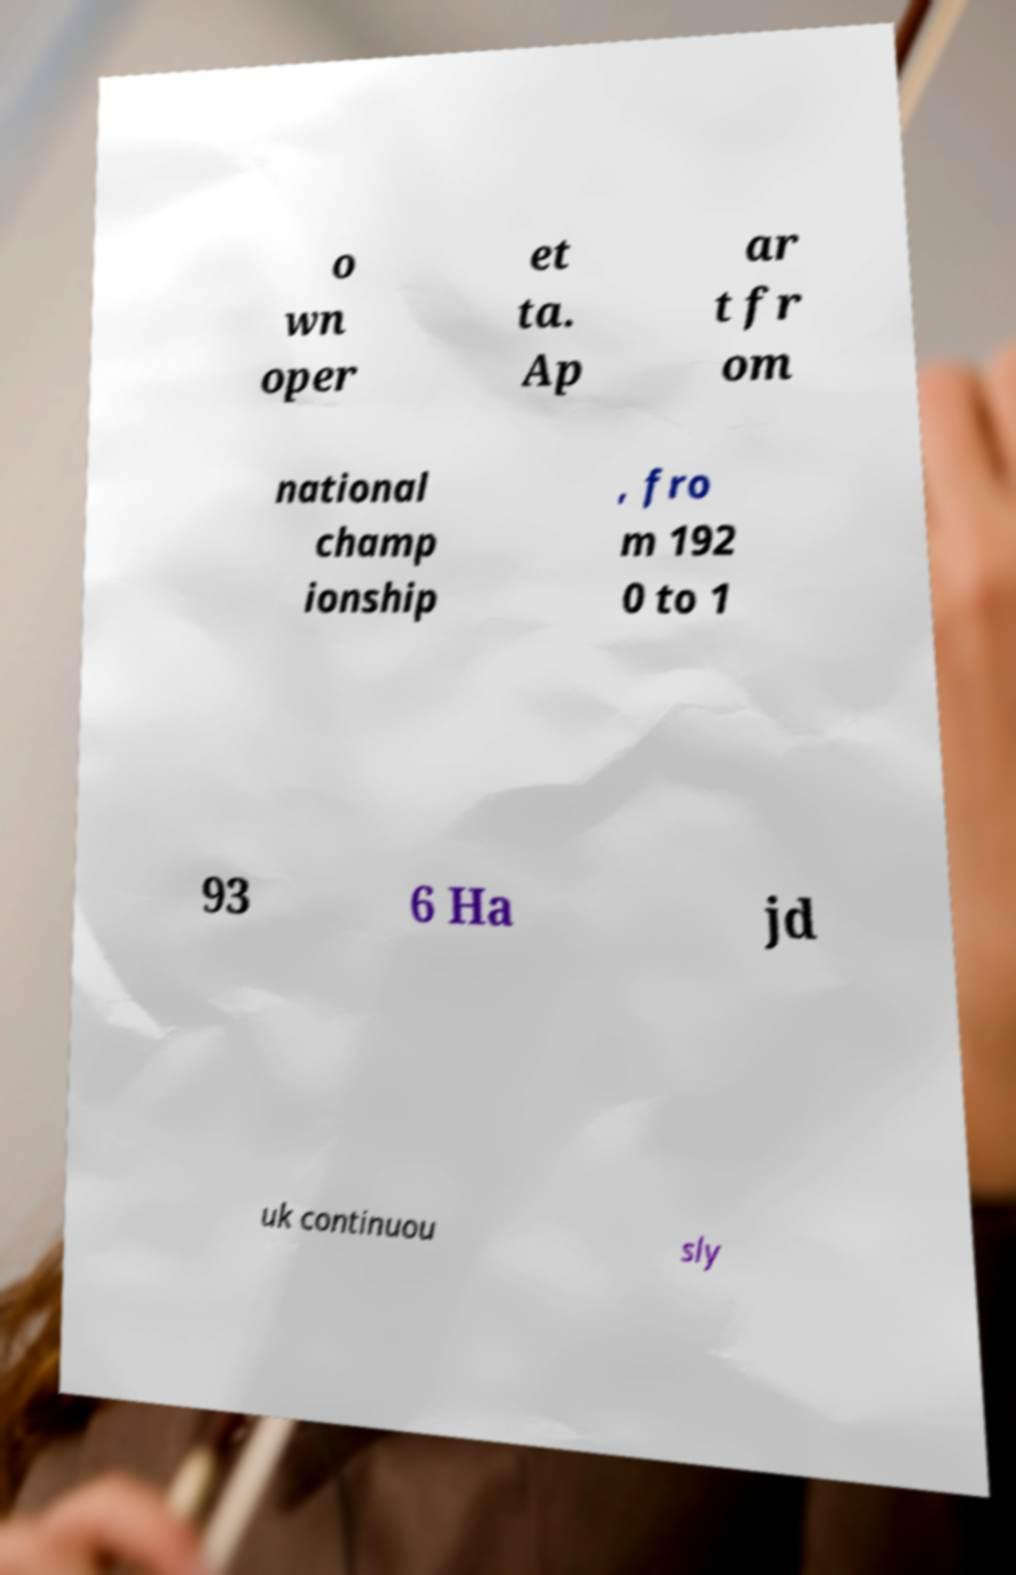Can you read and provide the text displayed in the image?This photo seems to have some interesting text. Can you extract and type it out for me? o wn oper et ta. Ap ar t fr om national champ ionship , fro m 192 0 to 1 93 6 Ha jd uk continuou sly 